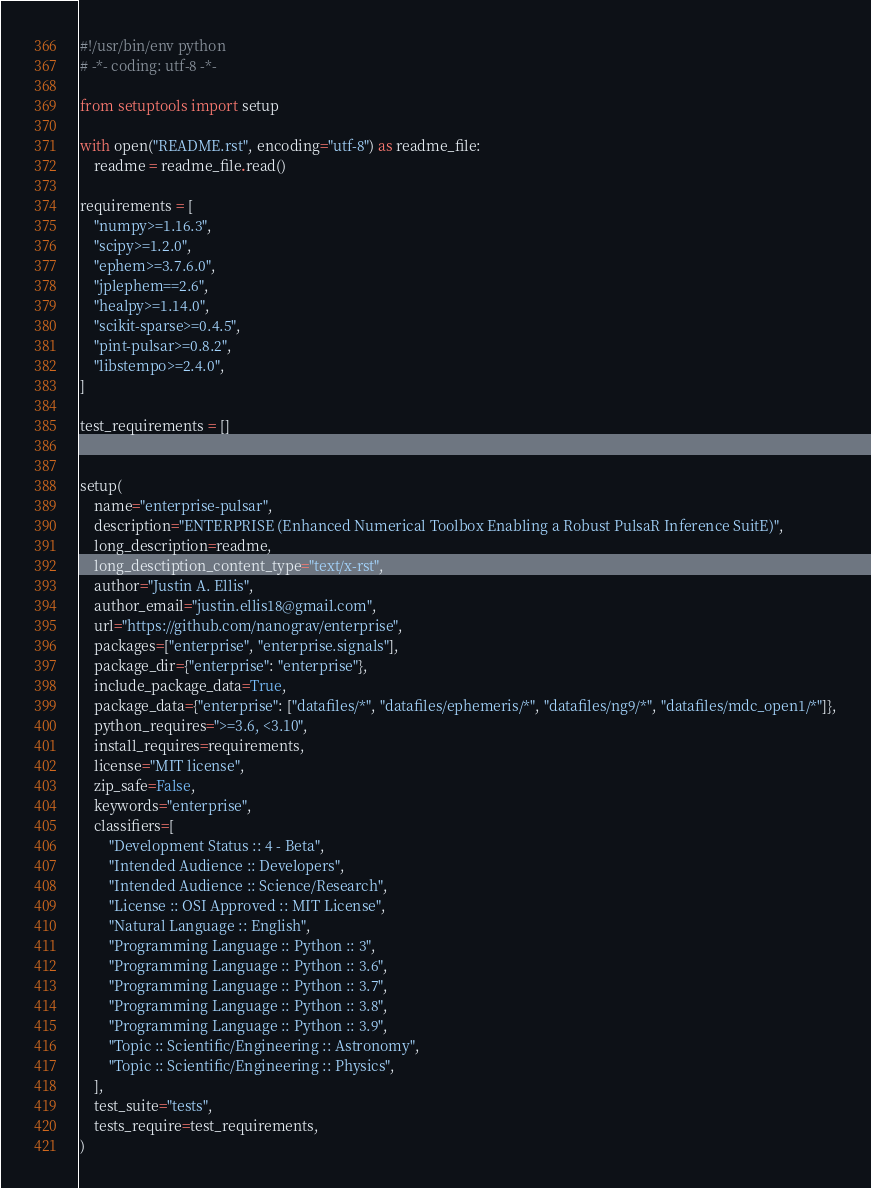<code> <loc_0><loc_0><loc_500><loc_500><_Python_>#!/usr/bin/env python
# -*- coding: utf-8 -*-

from setuptools import setup

with open("README.rst", encoding="utf-8") as readme_file:
    readme = readme_file.read()

requirements = [
    "numpy>=1.16.3",
    "scipy>=1.2.0",
    "ephem>=3.7.6.0",
    "jplephem==2.6",
    "healpy>=1.14.0",
    "scikit-sparse>=0.4.5",
    "pint-pulsar>=0.8.2",
    "libstempo>=2.4.0",
]

test_requirements = []


setup(
    name="enterprise-pulsar",
    description="ENTERPRISE (Enhanced Numerical Toolbox Enabling a Robust PulsaR Inference SuitE)",
    long_description=readme,
    long_desctiption_content_type="text/x-rst",
    author="Justin A. Ellis",
    author_email="justin.ellis18@gmail.com",
    url="https://github.com/nanograv/enterprise",
    packages=["enterprise", "enterprise.signals"],
    package_dir={"enterprise": "enterprise"},
    include_package_data=True,
    package_data={"enterprise": ["datafiles/*", "datafiles/ephemeris/*", "datafiles/ng9/*", "datafiles/mdc_open1/*"]},
    python_requires=">=3.6, <3.10",
    install_requires=requirements,
    license="MIT license",
    zip_safe=False,
    keywords="enterprise",
    classifiers=[
        "Development Status :: 4 - Beta",
        "Intended Audience :: Developers",
        "Intended Audience :: Science/Research",
        "License :: OSI Approved :: MIT License",
        "Natural Language :: English",
        "Programming Language :: Python :: 3",
        "Programming Language :: Python :: 3.6",
        "Programming Language :: Python :: 3.7",
        "Programming Language :: Python :: 3.8",
        "Programming Language :: Python :: 3.9",
        "Topic :: Scientific/Engineering :: Astronomy",
        "Topic :: Scientific/Engineering :: Physics",
    ],
    test_suite="tests",
    tests_require=test_requirements,
)
</code> 